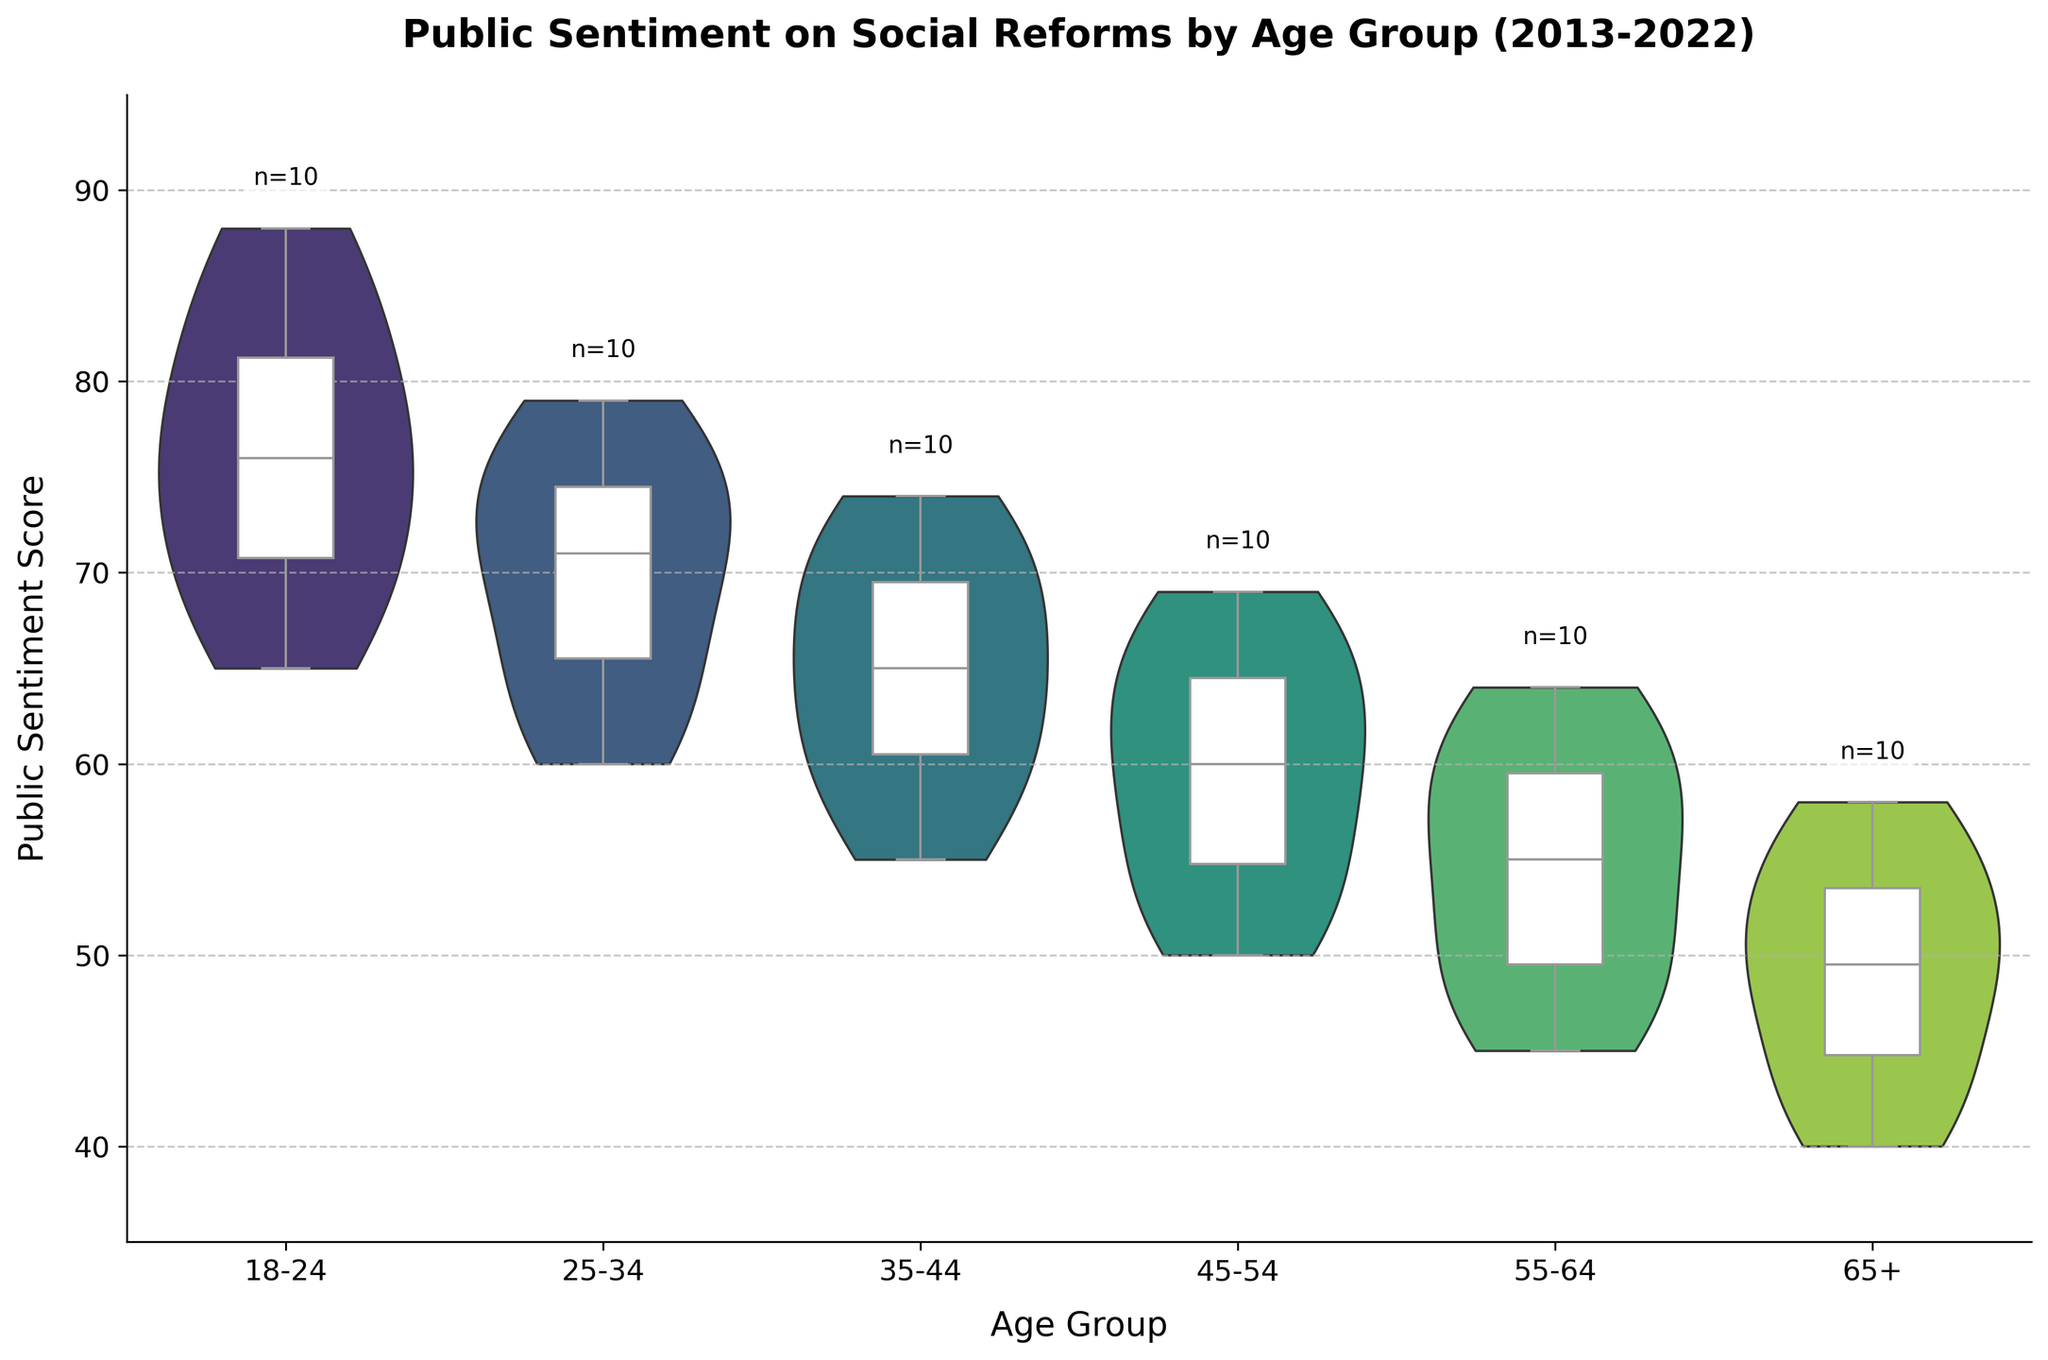What is the title of the figure? The title is prominently displayed at the top of the figure in bold letters. It reads, "Public Sentiment on Social Reforms by Age Group (2013-2022)."
Answer: Public Sentiment on Social Reforms by Age Group (2013-2022) What is the range of the y-axis? The range of the y-axis can be understood by looking at the lowest and highest values marked on it. The y-axis starts at 35 and ends at 95.
Answer: 35 to 95 What does the white box in each violin plot represent? The white box represents the interquartile range (IQR) of the public sentiment scores for each age group, showing the median and the range within which the middle 50% of the data lies.
Answer: Interquartile range (IQR) Which age group shows the highest median public sentiment score? By examining the box plots within each violin plot, the age group 18-24 shows the highest median sentiment score since the white box in its plot is positioned highest.
Answer: 18-24 How does the spread of public sentiment scores compare between the 18-24 and 65+ age groups? Looking at the width of the violin plots, the 18-24 group has a wider spread of scores, indicating more variability. The 65+ group has a narrower plot, showing less variability.
Answer: 18-24 has more variability Which age group has the smallest sample size of public sentiment scores? Each violin plot has a label indicating the number of data points ('n=10'). All groups have the same number of data points, n=10.
Answer: All groups have the same sample size Is there a visible upward trend in public sentiment scores across all age groups over the past decade? While the exact yearly data points are not visible, the overall position of the white boxes and the shape of the violins suggest a general upward trend across all age groups.
Answer: Yes Which two age groups have the closest median sentiment scores? Observing the white boxes within the violin plots, the groups 55-64 and 65+ have median lines on the box plots that are very close to each other, indicating similar median scores.
Answer: 55-64 and 65+ How does the variability of sentiment scores in the 45-54 age group compare to that in the 25-34 age group? The width of the violin plots indicates variability. The 45-54 group has a wider plot compared to the 25-34 group, suggesting higher variability in sentiment scores.
Answer: Higher in 45-54 Which age group has the largest interquartile range (IQR)? The IQR can be seen as the size of the white box in the violin plots. The 18-24 age group's white box is the largest, indicating the largest IQR.
Answer: 18-24 